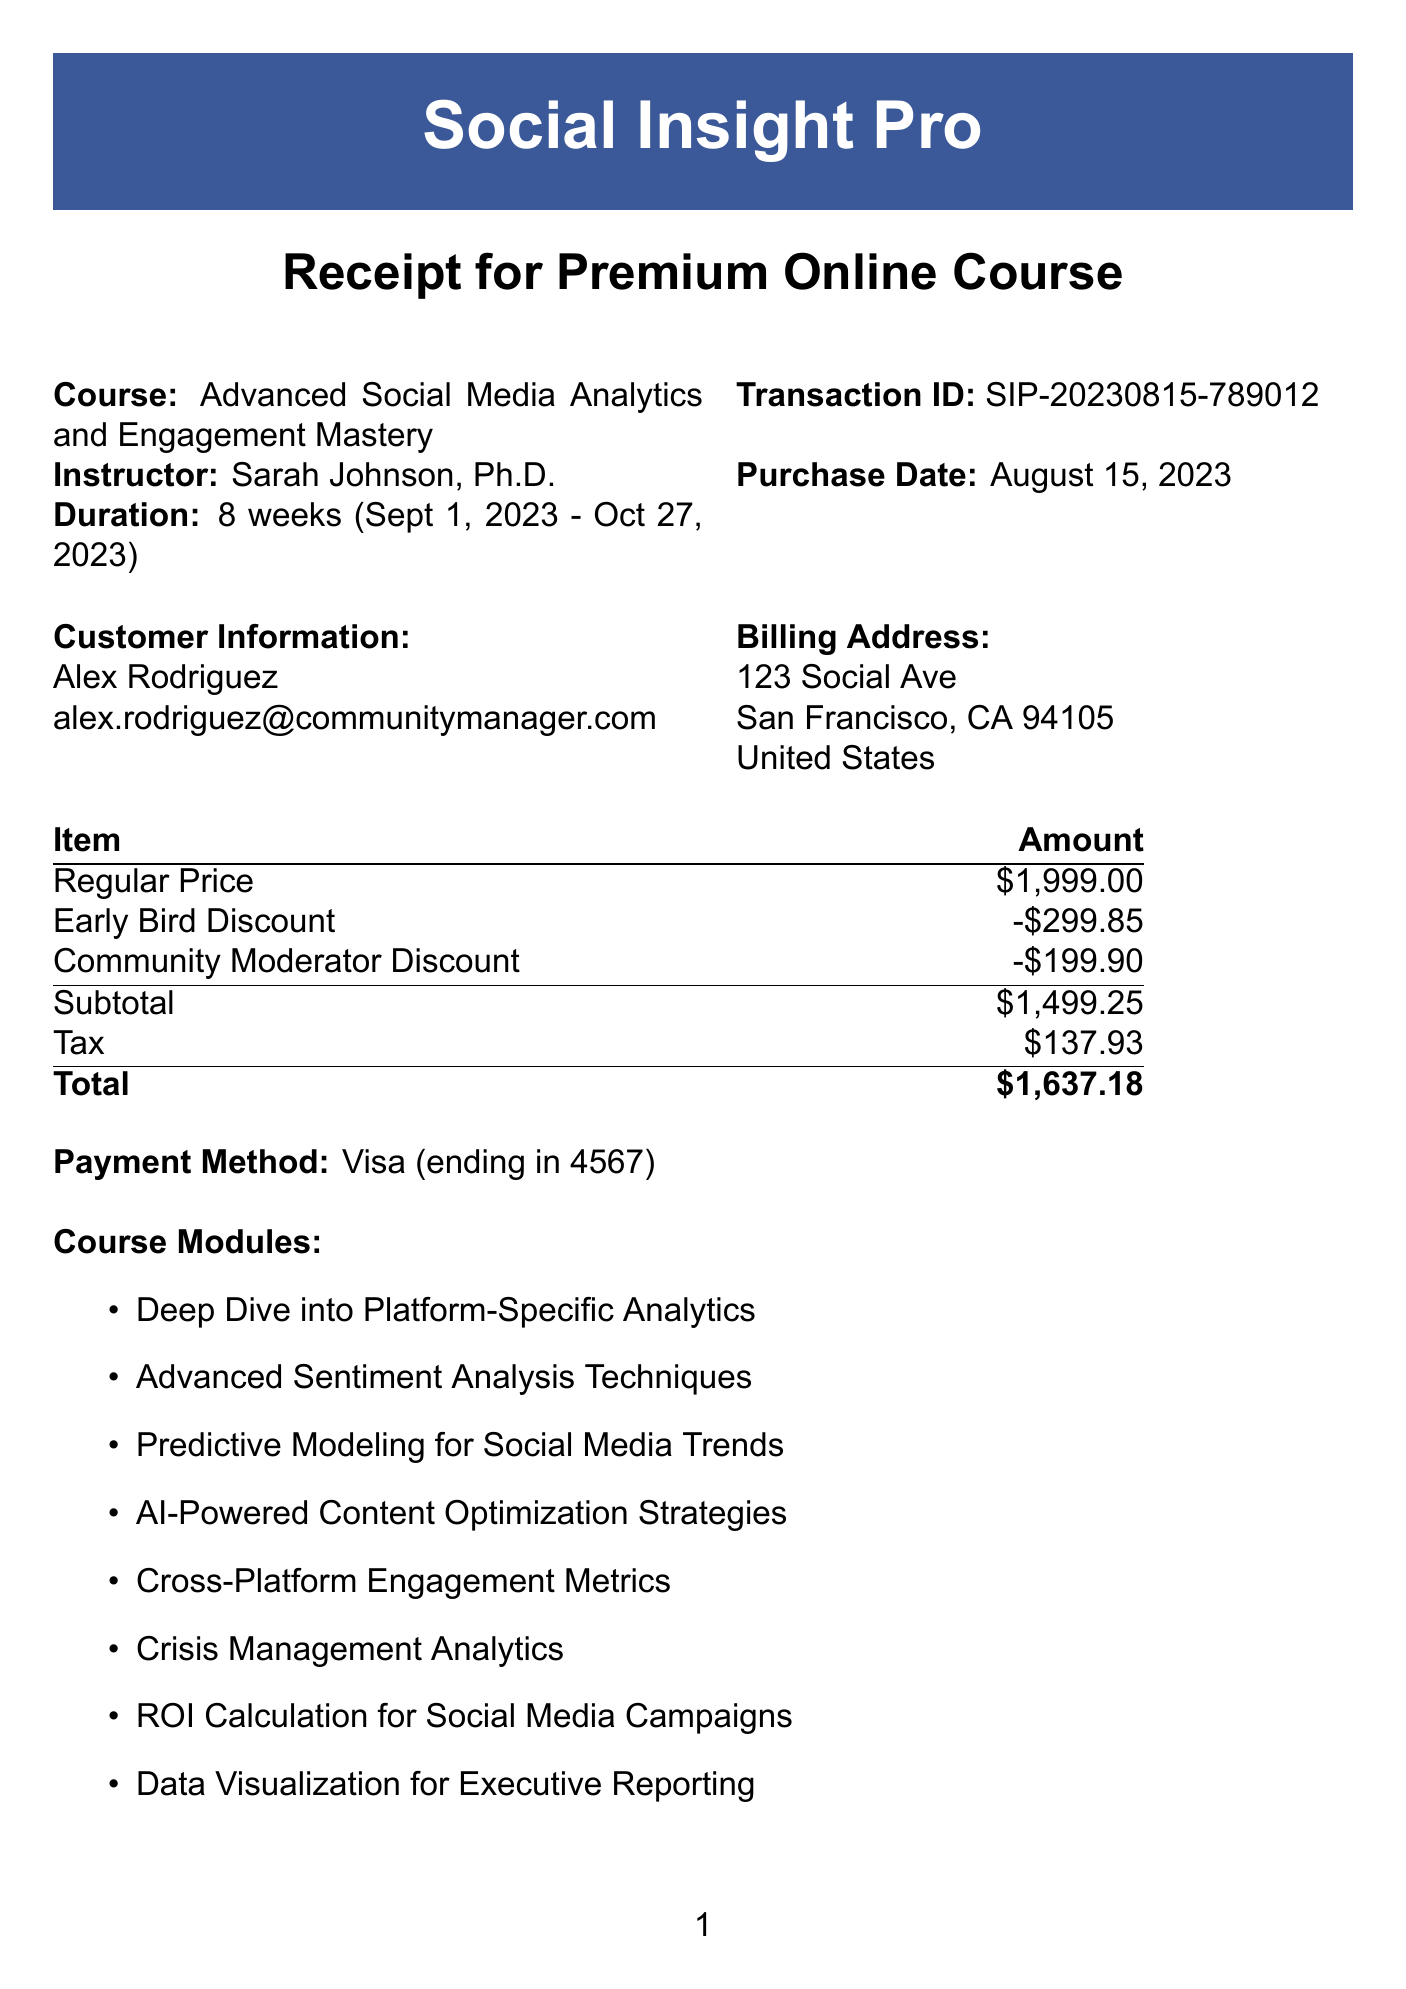What is the course name? The course name is listed at the top of the receipt.
Answer: Advanced Social Media Analytics and Engagement Mastery Who is the instructor? The instructor's name is mentioned in the document under the course details.
Answer: Sarah Johnson, Ph.D What is the duration of the course? The duration is specified in the course details section of the receipt.
Answer: 8 weeks What is the total amount paid? The total amount is the final charge shown at the end of the cost summary.
Answer: $1,637.18 What is the community moderator discount? The amount of the community moderator discount is stated in the pricing section.
Answer: -$199.90 When does the course start? The start date is mentioned in the course duration section of the document.
Answer: September 1, 2023 What is included in the bonus materials? The bonus materials are listed in a specific section.
Answer: 1-year subscription to Social Pro Analytics Suite What payment method was used? The payment method is stated in the payment details section of the receipt.
Answer: Visa What is the refund policy? The refund policy is a statement provided at the bottom of the document.
Answer: 14-day money-back guarantee 